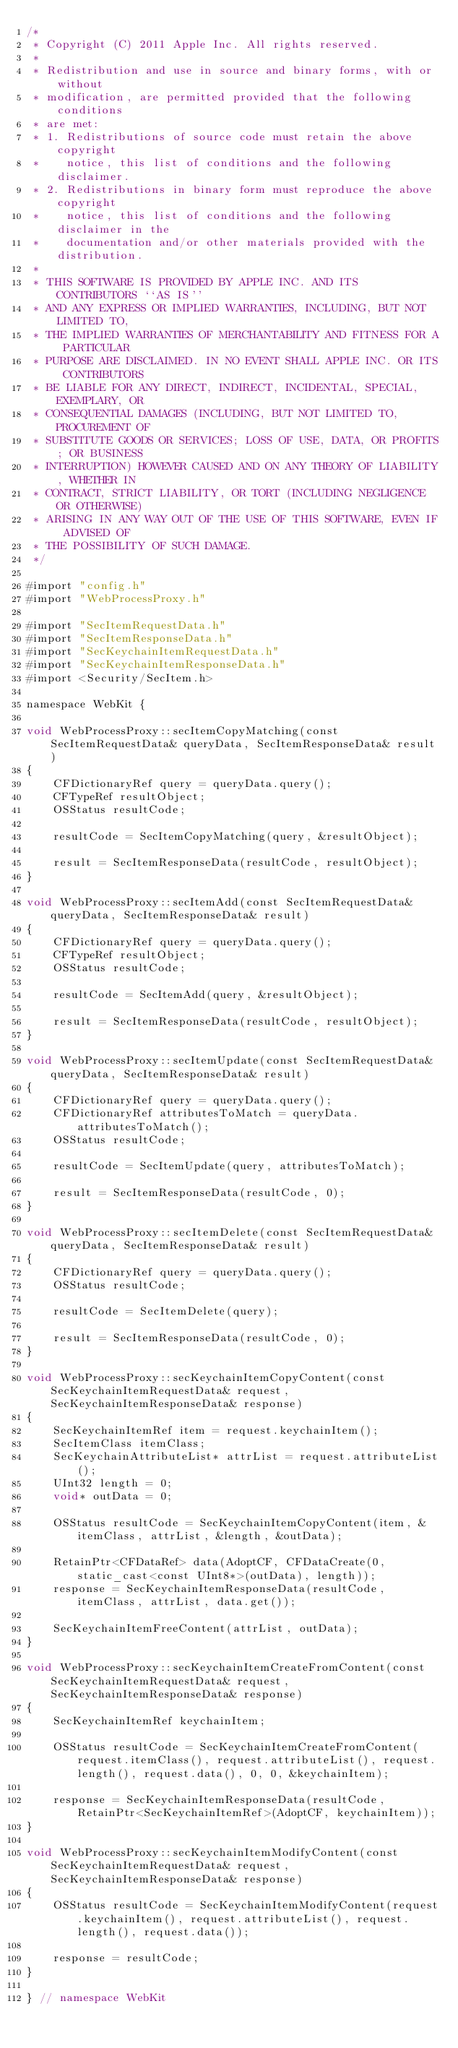<code> <loc_0><loc_0><loc_500><loc_500><_ObjectiveC_>/*
 * Copyright (C) 2011 Apple Inc. All rights reserved.
 *
 * Redistribution and use in source and binary forms, with or without
 * modification, are permitted provided that the following conditions
 * are met:
 * 1. Redistributions of source code must retain the above copyright
 *    notice, this list of conditions and the following disclaimer.
 * 2. Redistributions in binary form must reproduce the above copyright
 *    notice, this list of conditions and the following disclaimer in the
 *    documentation and/or other materials provided with the distribution.
 *
 * THIS SOFTWARE IS PROVIDED BY APPLE INC. AND ITS CONTRIBUTORS ``AS IS''
 * AND ANY EXPRESS OR IMPLIED WARRANTIES, INCLUDING, BUT NOT LIMITED TO,
 * THE IMPLIED WARRANTIES OF MERCHANTABILITY AND FITNESS FOR A PARTICULAR
 * PURPOSE ARE DISCLAIMED. IN NO EVENT SHALL APPLE INC. OR ITS CONTRIBUTORS
 * BE LIABLE FOR ANY DIRECT, INDIRECT, INCIDENTAL, SPECIAL, EXEMPLARY, OR
 * CONSEQUENTIAL DAMAGES (INCLUDING, BUT NOT LIMITED TO, PROCUREMENT OF
 * SUBSTITUTE GOODS OR SERVICES; LOSS OF USE, DATA, OR PROFITS; OR BUSINESS
 * INTERRUPTION) HOWEVER CAUSED AND ON ANY THEORY OF LIABILITY, WHETHER IN
 * CONTRACT, STRICT LIABILITY, OR TORT (INCLUDING NEGLIGENCE OR OTHERWISE)
 * ARISING IN ANY WAY OUT OF THE USE OF THIS SOFTWARE, EVEN IF ADVISED OF
 * THE POSSIBILITY OF SUCH DAMAGE.
 */
 
#import "config.h"
#import "WebProcessProxy.h"

#import "SecItemRequestData.h"
#import "SecItemResponseData.h"
#import "SecKeychainItemRequestData.h"
#import "SecKeychainItemResponseData.h"
#import <Security/SecItem.h>

namespace WebKit {

void WebProcessProxy::secItemCopyMatching(const SecItemRequestData& queryData, SecItemResponseData& result)
{
    CFDictionaryRef query = queryData.query();
    CFTypeRef resultObject;
    OSStatus resultCode;

    resultCode = SecItemCopyMatching(query, &resultObject);

    result = SecItemResponseData(resultCode, resultObject);
}

void WebProcessProxy::secItemAdd(const SecItemRequestData& queryData, SecItemResponseData& result)
{
    CFDictionaryRef query = queryData.query();
    CFTypeRef resultObject;
    OSStatus resultCode;

    resultCode = SecItemAdd(query, &resultObject);

    result = SecItemResponseData(resultCode, resultObject);
}

void WebProcessProxy::secItemUpdate(const SecItemRequestData& queryData, SecItemResponseData& result)
{
    CFDictionaryRef query = queryData.query();
    CFDictionaryRef attributesToMatch = queryData.attributesToMatch();
    OSStatus resultCode;

    resultCode = SecItemUpdate(query, attributesToMatch);

    result = SecItemResponseData(resultCode, 0);
}

void WebProcessProxy::secItemDelete(const SecItemRequestData& queryData, SecItemResponseData& result)
{
    CFDictionaryRef query = queryData.query();
    OSStatus resultCode;

    resultCode = SecItemDelete(query);

    result = SecItemResponseData(resultCode, 0);
}

void WebProcessProxy::secKeychainItemCopyContent(const SecKeychainItemRequestData& request, SecKeychainItemResponseData& response)
{
    SecKeychainItemRef item = request.keychainItem();
    SecItemClass itemClass;
    SecKeychainAttributeList* attrList = request.attributeList();    
    UInt32 length = 0;
    void* outData = 0;

    OSStatus resultCode = SecKeychainItemCopyContent(item, &itemClass, attrList, &length, &outData);
    
    RetainPtr<CFDataRef> data(AdoptCF, CFDataCreate(0, static_cast<const UInt8*>(outData), length));
    response = SecKeychainItemResponseData(resultCode, itemClass, attrList, data.get());
    
    SecKeychainItemFreeContent(attrList, outData);
}

void WebProcessProxy::secKeychainItemCreateFromContent(const SecKeychainItemRequestData& request, SecKeychainItemResponseData& response)
{
    SecKeychainItemRef keychainItem;
    
    OSStatus resultCode = SecKeychainItemCreateFromContent(request.itemClass(), request.attributeList(), request.length(), request.data(), 0, 0, &keychainItem);

    response = SecKeychainItemResponseData(resultCode, RetainPtr<SecKeychainItemRef>(AdoptCF, keychainItem));
}

void WebProcessProxy::secKeychainItemModifyContent(const SecKeychainItemRequestData& request, SecKeychainItemResponseData& response)
{
    OSStatus resultCode = SecKeychainItemModifyContent(request.keychainItem(), request.attributeList(), request.length(), request.data());
    
    response = resultCode;
}

} // namespace WebKit
</code> 